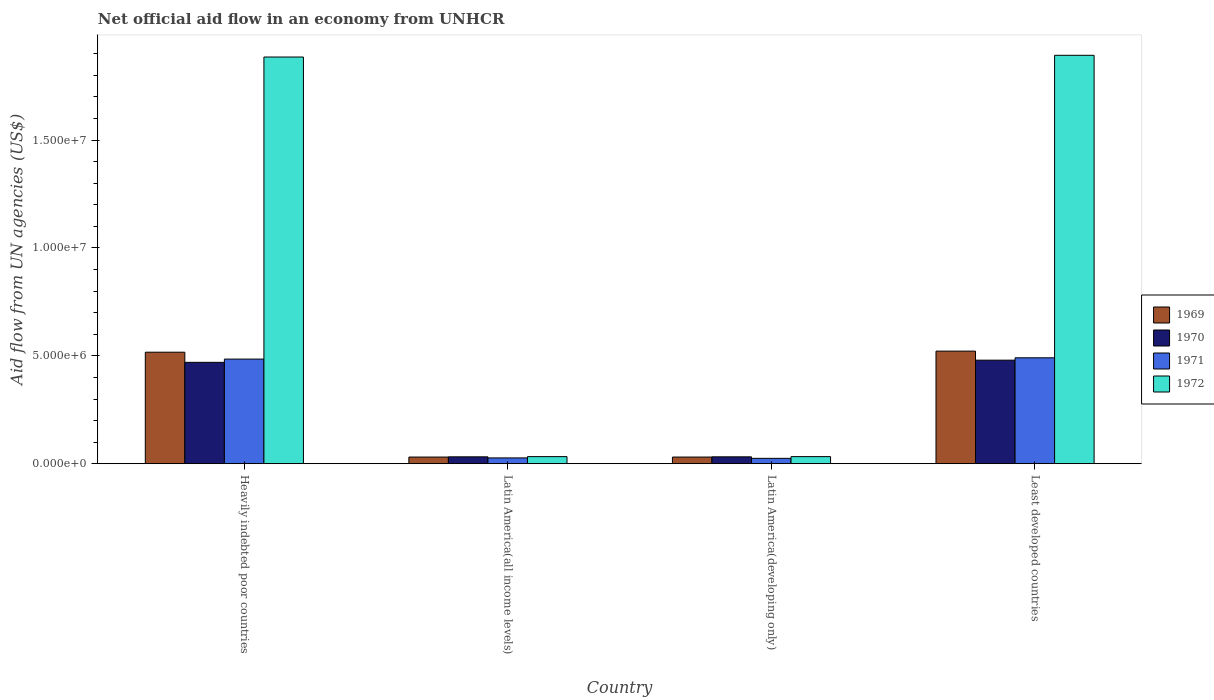How many different coloured bars are there?
Keep it short and to the point. 4. How many bars are there on the 3rd tick from the left?
Give a very brief answer. 4. How many bars are there on the 2nd tick from the right?
Make the answer very short. 4. What is the label of the 4th group of bars from the left?
Your response must be concise. Least developed countries. In how many cases, is the number of bars for a given country not equal to the number of legend labels?
Ensure brevity in your answer.  0. What is the net official aid flow in 1970 in Heavily indebted poor countries?
Ensure brevity in your answer.  4.70e+06. Across all countries, what is the maximum net official aid flow in 1972?
Offer a terse response. 1.89e+07. Across all countries, what is the minimum net official aid flow in 1971?
Provide a succinct answer. 2.50e+05. In which country was the net official aid flow in 1969 maximum?
Your answer should be very brief. Least developed countries. In which country was the net official aid flow in 1969 minimum?
Your answer should be very brief. Latin America(all income levels). What is the total net official aid flow in 1972 in the graph?
Provide a short and direct response. 3.84e+07. What is the difference between the net official aid flow in 1969 in Latin America(developing only) and that in Least developed countries?
Keep it short and to the point. -4.91e+06. What is the difference between the net official aid flow in 1969 in Latin America(all income levels) and the net official aid flow in 1970 in Latin America(developing only)?
Make the answer very short. -10000. What is the average net official aid flow in 1970 per country?
Give a very brief answer. 2.54e+06. What is the difference between the net official aid flow of/in 1969 and net official aid flow of/in 1972 in Heavily indebted poor countries?
Keep it short and to the point. -1.37e+07. In how many countries, is the net official aid flow in 1970 greater than 3000000 US$?
Provide a succinct answer. 2. What is the ratio of the net official aid flow in 1970 in Heavily indebted poor countries to that in Least developed countries?
Your answer should be compact. 0.98. What is the difference between the highest and the lowest net official aid flow in 1969?
Your answer should be very brief. 4.91e+06. In how many countries, is the net official aid flow in 1971 greater than the average net official aid flow in 1971 taken over all countries?
Your answer should be compact. 2. Is the sum of the net official aid flow in 1972 in Latin America(all income levels) and Least developed countries greater than the maximum net official aid flow in 1969 across all countries?
Offer a terse response. Yes. What does the 2nd bar from the left in Least developed countries represents?
Your answer should be very brief. 1970. How many countries are there in the graph?
Offer a very short reply. 4. What is the difference between two consecutive major ticks on the Y-axis?
Make the answer very short. 5.00e+06. Does the graph contain any zero values?
Give a very brief answer. No. Does the graph contain grids?
Your response must be concise. No. Where does the legend appear in the graph?
Your answer should be compact. Center right. What is the title of the graph?
Provide a succinct answer. Net official aid flow in an economy from UNHCR. What is the label or title of the Y-axis?
Offer a terse response. Aid flow from UN agencies (US$). What is the Aid flow from UN agencies (US$) of 1969 in Heavily indebted poor countries?
Your response must be concise. 5.17e+06. What is the Aid flow from UN agencies (US$) of 1970 in Heavily indebted poor countries?
Give a very brief answer. 4.70e+06. What is the Aid flow from UN agencies (US$) in 1971 in Heavily indebted poor countries?
Offer a very short reply. 4.85e+06. What is the Aid flow from UN agencies (US$) of 1972 in Heavily indebted poor countries?
Give a very brief answer. 1.88e+07. What is the Aid flow from UN agencies (US$) of 1971 in Latin America(developing only)?
Offer a terse response. 2.50e+05. What is the Aid flow from UN agencies (US$) in 1972 in Latin America(developing only)?
Make the answer very short. 3.30e+05. What is the Aid flow from UN agencies (US$) in 1969 in Least developed countries?
Offer a very short reply. 5.22e+06. What is the Aid flow from UN agencies (US$) in 1970 in Least developed countries?
Provide a succinct answer. 4.80e+06. What is the Aid flow from UN agencies (US$) in 1971 in Least developed countries?
Keep it short and to the point. 4.91e+06. What is the Aid flow from UN agencies (US$) of 1972 in Least developed countries?
Offer a very short reply. 1.89e+07. Across all countries, what is the maximum Aid flow from UN agencies (US$) of 1969?
Provide a succinct answer. 5.22e+06. Across all countries, what is the maximum Aid flow from UN agencies (US$) in 1970?
Provide a succinct answer. 4.80e+06. Across all countries, what is the maximum Aid flow from UN agencies (US$) in 1971?
Offer a terse response. 4.91e+06. Across all countries, what is the maximum Aid flow from UN agencies (US$) of 1972?
Keep it short and to the point. 1.89e+07. Across all countries, what is the minimum Aid flow from UN agencies (US$) of 1970?
Provide a succinct answer. 3.20e+05. What is the total Aid flow from UN agencies (US$) of 1969 in the graph?
Provide a succinct answer. 1.10e+07. What is the total Aid flow from UN agencies (US$) in 1970 in the graph?
Offer a terse response. 1.01e+07. What is the total Aid flow from UN agencies (US$) in 1971 in the graph?
Provide a short and direct response. 1.03e+07. What is the total Aid flow from UN agencies (US$) in 1972 in the graph?
Your response must be concise. 3.84e+07. What is the difference between the Aid flow from UN agencies (US$) of 1969 in Heavily indebted poor countries and that in Latin America(all income levels)?
Offer a terse response. 4.86e+06. What is the difference between the Aid flow from UN agencies (US$) of 1970 in Heavily indebted poor countries and that in Latin America(all income levels)?
Make the answer very short. 4.38e+06. What is the difference between the Aid flow from UN agencies (US$) of 1971 in Heavily indebted poor countries and that in Latin America(all income levels)?
Provide a short and direct response. 4.58e+06. What is the difference between the Aid flow from UN agencies (US$) of 1972 in Heavily indebted poor countries and that in Latin America(all income levels)?
Keep it short and to the point. 1.85e+07. What is the difference between the Aid flow from UN agencies (US$) of 1969 in Heavily indebted poor countries and that in Latin America(developing only)?
Give a very brief answer. 4.86e+06. What is the difference between the Aid flow from UN agencies (US$) in 1970 in Heavily indebted poor countries and that in Latin America(developing only)?
Make the answer very short. 4.38e+06. What is the difference between the Aid flow from UN agencies (US$) in 1971 in Heavily indebted poor countries and that in Latin America(developing only)?
Offer a very short reply. 4.60e+06. What is the difference between the Aid flow from UN agencies (US$) in 1972 in Heavily indebted poor countries and that in Latin America(developing only)?
Your response must be concise. 1.85e+07. What is the difference between the Aid flow from UN agencies (US$) in 1970 in Heavily indebted poor countries and that in Least developed countries?
Your answer should be very brief. -1.00e+05. What is the difference between the Aid flow from UN agencies (US$) in 1971 in Heavily indebted poor countries and that in Least developed countries?
Ensure brevity in your answer.  -6.00e+04. What is the difference between the Aid flow from UN agencies (US$) in 1972 in Heavily indebted poor countries and that in Least developed countries?
Provide a short and direct response. -8.00e+04. What is the difference between the Aid flow from UN agencies (US$) of 1969 in Latin America(all income levels) and that in Least developed countries?
Make the answer very short. -4.91e+06. What is the difference between the Aid flow from UN agencies (US$) of 1970 in Latin America(all income levels) and that in Least developed countries?
Offer a terse response. -4.48e+06. What is the difference between the Aid flow from UN agencies (US$) in 1971 in Latin America(all income levels) and that in Least developed countries?
Provide a short and direct response. -4.64e+06. What is the difference between the Aid flow from UN agencies (US$) of 1972 in Latin America(all income levels) and that in Least developed countries?
Provide a short and direct response. -1.86e+07. What is the difference between the Aid flow from UN agencies (US$) of 1969 in Latin America(developing only) and that in Least developed countries?
Give a very brief answer. -4.91e+06. What is the difference between the Aid flow from UN agencies (US$) in 1970 in Latin America(developing only) and that in Least developed countries?
Offer a very short reply. -4.48e+06. What is the difference between the Aid flow from UN agencies (US$) of 1971 in Latin America(developing only) and that in Least developed countries?
Make the answer very short. -4.66e+06. What is the difference between the Aid flow from UN agencies (US$) of 1972 in Latin America(developing only) and that in Least developed countries?
Your answer should be compact. -1.86e+07. What is the difference between the Aid flow from UN agencies (US$) of 1969 in Heavily indebted poor countries and the Aid flow from UN agencies (US$) of 1970 in Latin America(all income levels)?
Your answer should be very brief. 4.85e+06. What is the difference between the Aid flow from UN agencies (US$) of 1969 in Heavily indebted poor countries and the Aid flow from UN agencies (US$) of 1971 in Latin America(all income levels)?
Keep it short and to the point. 4.90e+06. What is the difference between the Aid flow from UN agencies (US$) in 1969 in Heavily indebted poor countries and the Aid flow from UN agencies (US$) in 1972 in Latin America(all income levels)?
Your response must be concise. 4.84e+06. What is the difference between the Aid flow from UN agencies (US$) in 1970 in Heavily indebted poor countries and the Aid flow from UN agencies (US$) in 1971 in Latin America(all income levels)?
Ensure brevity in your answer.  4.43e+06. What is the difference between the Aid flow from UN agencies (US$) of 1970 in Heavily indebted poor countries and the Aid flow from UN agencies (US$) of 1972 in Latin America(all income levels)?
Keep it short and to the point. 4.37e+06. What is the difference between the Aid flow from UN agencies (US$) in 1971 in Heavily indebted poor countries and the Aid flow from UN agencies (US$) in 1972 in Latin America(all income levels)?
Provide a succinct answer. 4.52e+06. What is the difference between the Aid flow from UN agencies (US$) in 1969 in Heavily indebted poor countries and the Aid flow from UN agencies (US$) in 1970 in Latin America(developing only)?
Ensure brevity in your answer.  4.85e+06. What is the difference between the Aid flow from UN agencies (US$) in 1969 in Heavily indebted poor countries and the Aid flow from UN agencies (US$) in 1971 in Latin America(developing only)?
Ensure brevity in your answer.  4.92e+06. What is the difference between the Aid flow from UN agencies (US$) of 1969 in Heavily indebted poor countries and the Aid flow from UN agencies (US$) of 1972 in Latin America(developing only)?
Make the answer very short. 4.84e+06. What is the difference between the Aid flow from UN agencies (US$) of 1970 in Heavily indebted poor countries and the Aid flow from UN agencies (US$) of 1971 in Latin America(developing only)?
Provide a short and direct response. 4.45e+06. What is the difference between the Aid flow from UN agencies (US$) in 1970 in Heavily indebted poor countries and the Aid flow from UN agencies (US$) in 1972 in Latin America(developing only)?
Provide a succinct answer. 4.37e+06. What is the difference between the Aid flow from UN agencies (US$) of 1971 in Heavily indebted poor countries and the Aid flow from UN agencies (US$) of 1972 in Latin America(developing only)?
Your answer should be very brief. 4.52e+06. What is the difference between the Aid flow from UN agencies (US$) in 1969 in Heavily indebted poor countries and the Aid flow from UN agencies (US$) in 1971 in Least developed countries?
Your response must be concise. 2.60e+05. What is the difference between the Aid flow from UN agencies (US$) in 1969 in Heavily indebted poor countries and the Aid flow from UN agencies (US$) in 1972 in Least developed countries?
Your response must be concise. -1.38e+07. What is the difference between the Aid flow from UN agencies (US$) in 1970 in Heavily indebted poor countries and the Aid flow from UN agencies (US$) in 1971 in Least developed countries?
Give a very brief answer. -2.10e+05. What is the difference between the Aid flow from UN agencies (US$) of 1970 in Heavily indebted poor countries and the Aid flow from UN agencies (US$) of 1972 in Least developed countries?
Offer a very short reply. -1.42e+07. What is the difference between the Aid flow from UN agencies (US$) in 1971 in Heavily indebted poor countries and the Aid flow from UN agencies (US$) in 1972 in Least developed countries?
Your answer should be very brief. -1.41e+07. What is the difference between the Aid flow from UN agencies (US$) of 1970 in Latin America(all income levels) and the Aid flow from UN agencies (US$) of 1971 in Latin America(developing only)?
Your answer should be very brief. 7.00e+04. What is the difference between the Aid flow from UN agencies (US$) of 1971 in Latin America(all income levels) and the Aid flow from UN agencies (US$) of 1972 in Latin America(developing only)?
Your answer should be very brief. -6.00e+04. What is the difference between the Aid flow from UN agencies (US$) in 1969 in Latin America(all income levels) and the Aid flow from UN agencies (US$) in 1970 in Least developed countries?
Give a very brief answer. -4.49e+06. What is the difference between the Aid flow from UN agencies (US$) of 1969 in Latin America(all income levels) and the Aid flow from UN agencies (US$) of 1971 in Least developed countries?
Provide a succinct answer. -4.60e+06. What is the difference between the Aid flow from UN agencies (US$) in 1969 in Latin America(all income levels) and the Aid flow from UN agencies (US$) in 1972 in Least developed countries?
Keep it short and to the point. -1.86e+07. What is the difference between the Aid flow from UN agencies (US$) in 1970 in Latin America(all income levels) and the Aid flow from UN agencies (US$) in 1971 in Least developed countries?
Your answer should be very brief. -4.59e+06. What is the difference between the Aid flow from UN agencies (US$) of 1970 in Latin America(all income levels) and the Aid flow from UN agencies (US$) of 1972 in Least developed countries?
Offer a terse response. -1.86e+07. What is the difference between the Aid flow from UN agencies (US$) of 1971 in Latin America(all income levels) and the Aid flow from UN agencies (US$) of 1972 in Least developed countries?
Keep it short and to the point. -1.87e+07. What is the difference between the Aid flow from UN agencies (US$) in 1969 in Latin America(developing only) and the Aid flow from UN agencies (US$) in 1970 in Least developed countries?
Keep it short and to the point. -4.49e+06. What is the difference between the Aid flow from UN agencies (US$) of 1969 in Latin America(developing only) and the Aid flow from UN agencies (US$) of 1971 in Least developed countries?
Keep it short and to the point. -4.60e+06. What is the difference between the Aid flow from UN agencies (US$) in 1969 in Latin America(developing only) and the Aid flow from UN agencies (US$) in 1972 in Least developed countries?
Offer a very short reply. -1.86e+07. What is the difference between the Aid flow from UN agencies (US$) of 1970 in Latin America(developing only) and the Aid flow from UN agencies (US$) of 1971 in Least developed countries?
Your answer should be compact. -4.59e+06. What is the difference between the Aid flow from UN agencies (US$) of 1970 in Latin America(developing only) and the Aid flow from UN agencies (US$) of 1972 in Least developed countries?
Provide a short and direct response. -1.86e+07. What is the difference between the Aid flow from UN agencies (US$) of 1971 in Latin America(developing only) and the Aid flow from UN agencies (US$) of 1972 in Least developed countries?
Give a very brief answer. -1.87e+07. What is the average Aid flow from UN agencies (US$) in 1969 per country?
Ensure brevity in your answer.  2.75e+06. What is the average Aid flow from UN agencies (US$) in 1970 per country?
Offer a terse response. 2.54e+06. What is the average Aid flow from UN agencies (US$) in 1971 per country?
Give a very brief answer. 2.57e+06. What is the average Aid flow from UN agencies (US$) in 1972 per country?
Your answer should be compact. 9.61e+06. What is the difference between the Aid flow from UN agencies (US$) of 1969 and Aid flow from UN agencies (US$) of 1970 in Heavily indebted poor countries?
Offer a very short reply. 4.70e+05. What is the difference between the Aid flow from UN agencies (US$) of 1969 and Aid flow from UN agencies (US$) of 1971 in Heavily indebted poor countries?
Provide a succinct answer. 3.20e+05. What is the difference between the Aid flow from UN agencies (US$) in 1969 and Aid flow from UN agencies (US$) in 1972 in Heavily indebted poor countries?
Your answer should be very brief. -1.37e+07. What is the difference between the Aid flow from UN agencies (US$) of 1970 and Aid flow from UN agencies (US$) of 1972 in Heavily indebted poor countries?
Offer a very short reply. -1.42e+07. What is the difference between the Aid flow from UN agencies (US$) of 1971 and Aid flow from UN agencies (US$) of 1972 in Heavily indebted poor countries?
Keep it short and to the point. -1.40e+07. What is the difference between the Aid flow from UN agencies (US$) in 1970 and Aid flow from UN agencies (US$) in 1971 in Latin America(all income levels)?
Provide a short and direct response. 5.00e+04. What is the difference between the Aid flow from UN agencies (US$) of 1970 and Aid flow from UN agencies (US$) of 1972 in Latin America(all income levels)?
Your answer should be compact. -10000. What is the difference between the Aid flow from UN agencies (US$) of 1969 and Aid flow from UN agencies (US$) of 1971 in Latin America(developing only)?
Keep it short and to the point. 6.00e+04. What is the difference between the Aid flow from UN agencies (US$) in 1969 and Aid flow from UN agencies (US$) in 1970 in Least developed countries?
Give a very brief answer. 4.20e+05. What is the difference between the Aid flow from UN agencies (US$) in 1969 and Aid flow from UN agencies (US$) in 1971 in Least developed countries?
Give a very brief answer. 3.10e+05. What is the difference between the Aid flow from UN agencies (US$) in 1969 and Aid flow from UN agencies (US$) in 1972 in Least developed countries?
Make the answer very short. -1.37e+07. What is the difference between the Aid flow from UN agencies (US$) of 1970 and Aid flow from UN agencies (US$) of 1971 in Least developed countries?
Provide a succinct answer. -1.10e+05. What is the difference between the Aid flow from UN agencies (US$) of 1970 and Aid flow from UN agencies (US$) of 1972 in Least developed countries?
Your answer should be very brief. -1.41e+07. What is the difference between the Aid flow from UN agencies (US$) in 1971 and Aid flow from UN agencies (US$) in 1972 in Least developed countries?
Give a very brief answer. -1.40e+07. What is the ratio of the Aid flow from UN agencies (US$) in 1969 in Heavily indebted poor countries to that in Latin America(all income levels)?
Offer a very short reply. 16.68. What is the ratio of the Aid flow from UN agencies (US$) of 1970 in Heavily indebted poor countries to that in Latin America(all income levels)?
Provide a succinct answer. 14.69. What is the ratio of the Aid flow from UN agencies (US$) of 1971 in Heavily indebted poor countries to that in Latin America(all income levels)?
Offer a very short reply. 17.96. What is the ratio of the Aid flow from UN agencies (US$) in 1972 in Heavily indebted poor countries to that in Latin America(all income levels)?
Keep it short and to the point. 57.12. What is the ratio of the Aid flow from UN agencies (US$) in 1969 in Heavily indebted poor countries to that in Latin America(developing only)?
Provide a short and direct response. 16.68. What is the ratio of the Aid flow from UN agencies (US$) of 1970 in Heavily indebted poor countries to that in Latin America(developing only)?
Ensure brevity in your answer.  14.69. What is the ratio of the Aid flow from UN agencies (US$) in 1972 in Heavily indebted poor countries to that in Latin America(developing only)?
Offer a very short reply. 57.12. What is the ratio of the Aid flow from UN agencies (US$) in 1970 in Heavily indebted poor countries to that in Least developed countries?
Keep it short and to the point. 0.98. What is the ratio of the Aid flow from UN agencies (US$) in 1972 in Latin America(all income levels) to that in Latin America(developing only)?
Give a very brief answer. 1. What is the ratio of the Aid flow from UN agencies (US$) of 1969 in Latin America(all income levels) to that in Least developed countries?
Your answer should be compact. 0.06. What is the ratio of the Aid flow from UN agencies (US$) of 1970 in Latin America(all income levels) to that in Least developed countries?
Keep it short and to the point. 0.07. What is the ratio of the Aid flow from UN agencies (US$) in 1971 in Latin America(all income levels) to that in Least developed countries?
Provide a short and direct response. 0.06. What is the ratio of the Aid flow from UN agencies (US$) of 1972 in Latin America(all income levels) to that in Least developed countries?
Give a very brief answer. 0.02. What is the ratio of the Aid flow from UN agencies (US$) in 1969 in Latin America(developing only) to that in Least developed countries?
Make the answer very short. 0.06. What is the ratio of the Aid flow from UN agencies (US$) in 1970 in Latin America(developing only) to that in Least developed countries?
Give a very brief answer. 0.07. What is the ratio of the Aid flow from UN agencies (US$) in 1971 in Latin America(developing only) to that in Least developed countries?
Your answer should be very brief. 0.05. What is the ratio of the Aid flow from UN agencies (US$) of 1972 in Latin America(developing only) to that in Least developed countries?
Your answer should be very brief. 0.02. What is the difference between the highest and the second highest Aid flow from UN agencies (US$) of 1969?
Ensure brevity in your answer.  5.00e+04. What is the difference between the highest and the lowest Aid flow from UN agencies (US$) of 1969?
Your answer should be very brief. 4.91e+06. What is the difference between the highest and the lowest Aid flow from UN agencies (US$) of 1970?
Offer a very short reply. 4.48e+06. What is the difference between the highest and the lowest Aid flow from UN agencies (US$) of 1971?
Your answer should be compact. 4.66e+06. What is the difference between the highest and the lowest Aid flow from UN agencies (US$) of 1972?
Offer a terse response. 1.86e+07. 